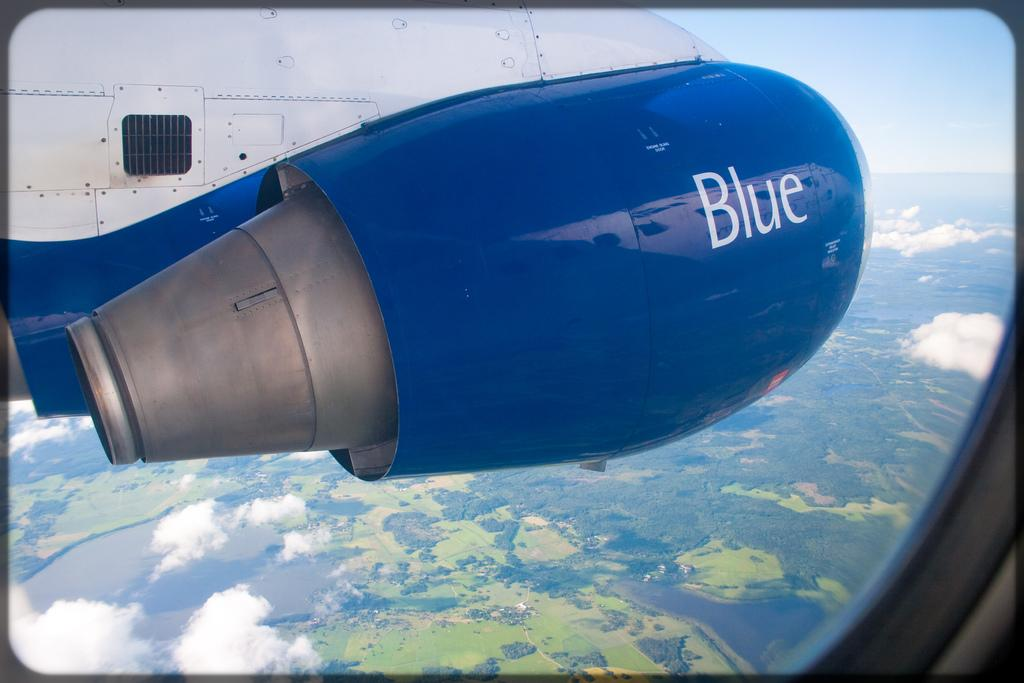What is the perspective of the image? The image is captured from a plane. What part of the plane can be seen in the image? A part of the plane is visible behind the window. What is the primary feature of the image? Beautiful greenery is visible in the image. What else can be seen in the sky in the image? Clouds are visible in the image. Can you see the father feeding the goldfish in the image? There is no father or goldfish present in the image; it features a view from a plane with greenery and clouds. 